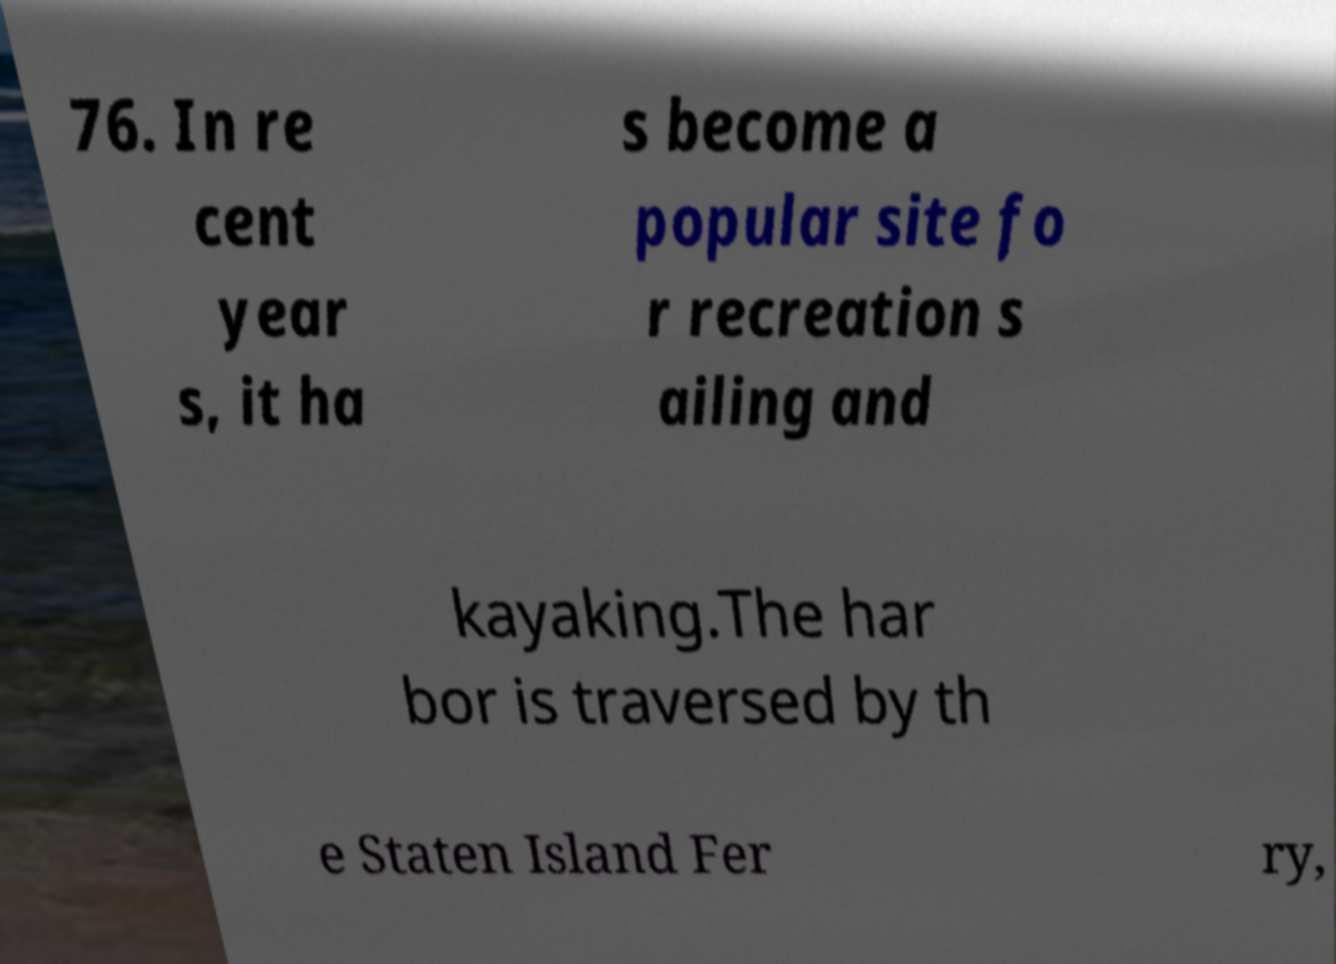For documentation purposes, I need the text within this image transcribed. Could you provide that? 76. In re cent year s, it ha s become a popular site fo r recreation s ailing and kayaking.The har bor is traversed by th e Staten Island Fer ry, 